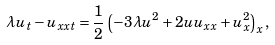<formula> <loc_0><loc_0><loc_500><loc_500>\lambda u _ { t } - u _ { x x t } = \frac { 1 } { 2 } \left ( - 3 \lambda u ^ { 2 } + 2 u u _ { x x } + u _ { x } ^ { 2 } \right ) _ { x } ,</formula> 